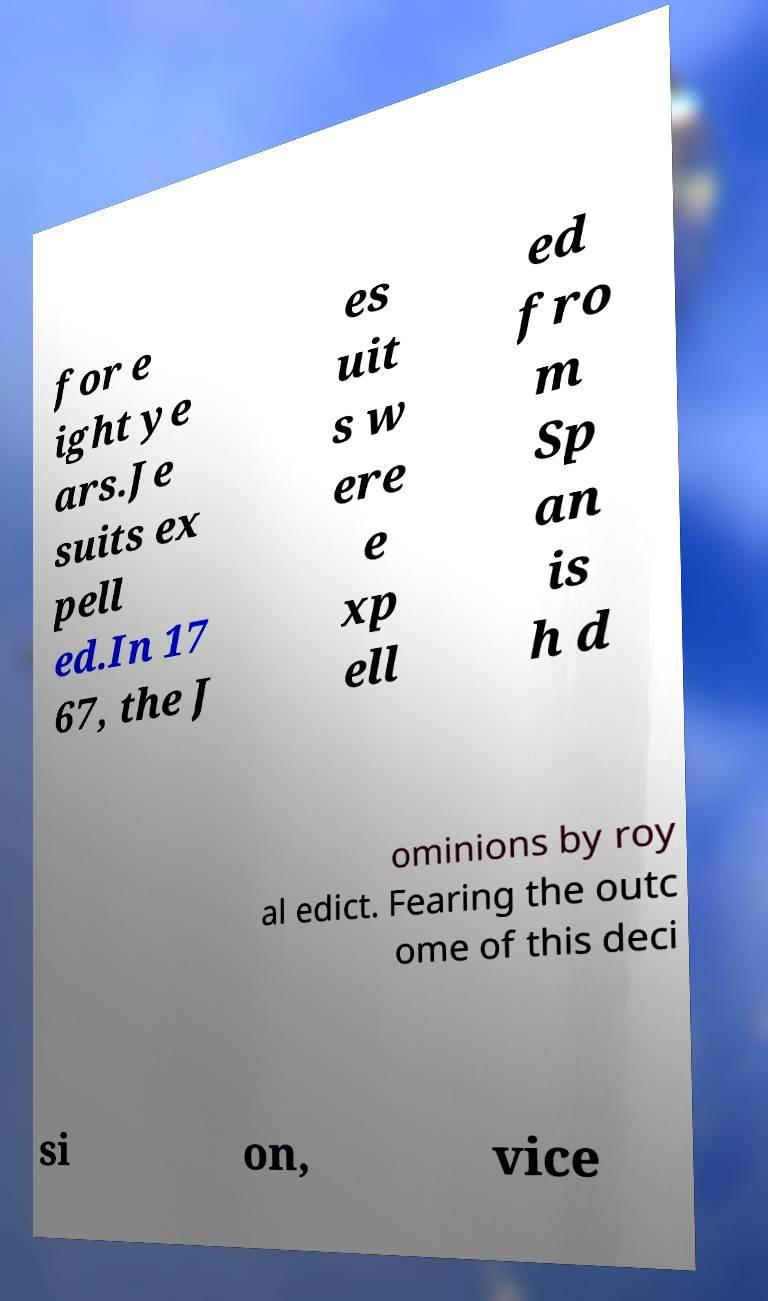I need the written content from this picture converted into text. Can you do that? for e ight ye ars.Je suits ex pell ed.In 17 67, the J es uit s w ere e xp ell ed fro m Sp an is h d ominions by roy al edict. Fearing the outc ome of this deci si on, vice 